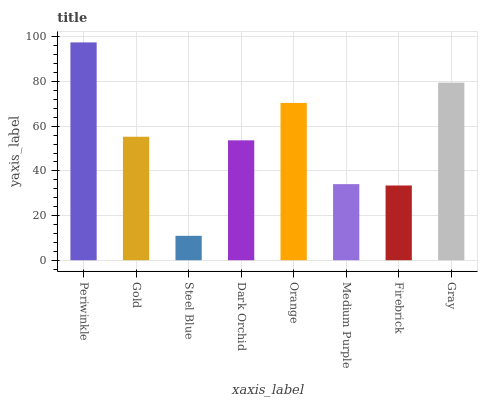Is Steel Blue the minimum?
Answer yes or no. Yes. Is Periwinkle the maximum?
Answer yes or no. Yes. Is Gold the minimum?
Answer yes or no. No. Is Gold the maximum?
Answer yes or no. No. Is Periwinkle greater than Gold?
Answer yes or no. Yes. Is Gold less than Periwinkle?
Answer yes or no. Yes. Is Gold greater than Periwinkle?
Answer yes or no. No. Is Periwinkle less than Gold?
Answer yes or no. No. Is Gold the high median?
Answer yes or no. Yes. Is Dark Orchid the low median?
Answer yes or no. Yes. Is Steel Blue the high median?
Answer yes or no. No. Is Orange the low median?
Answer yes or no. No. 